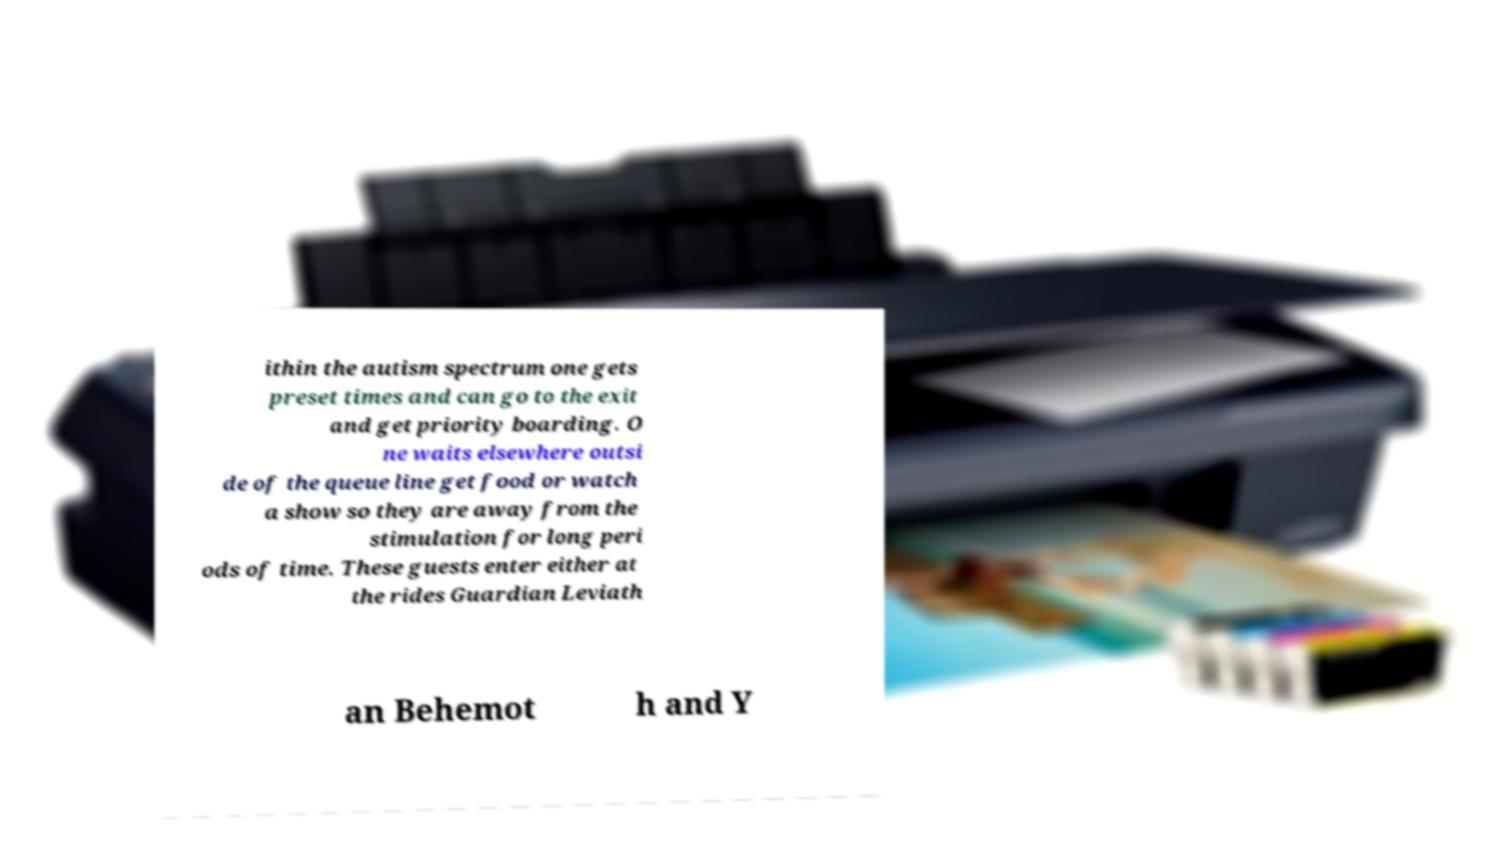Can you read and provide the text displayed in the image?This photo seems to have some interesting text. Can you extract and type it out for me? ithin the autism spectrum one gets preset times and can go to the exit and get priority boarding. O ne waits elsewhere outsi de of the queue line get food or watch a show so they are away from the stimulation for long peri ods of time. These guests enter either at the rides Guardian Leviath an Behemot h and Y 